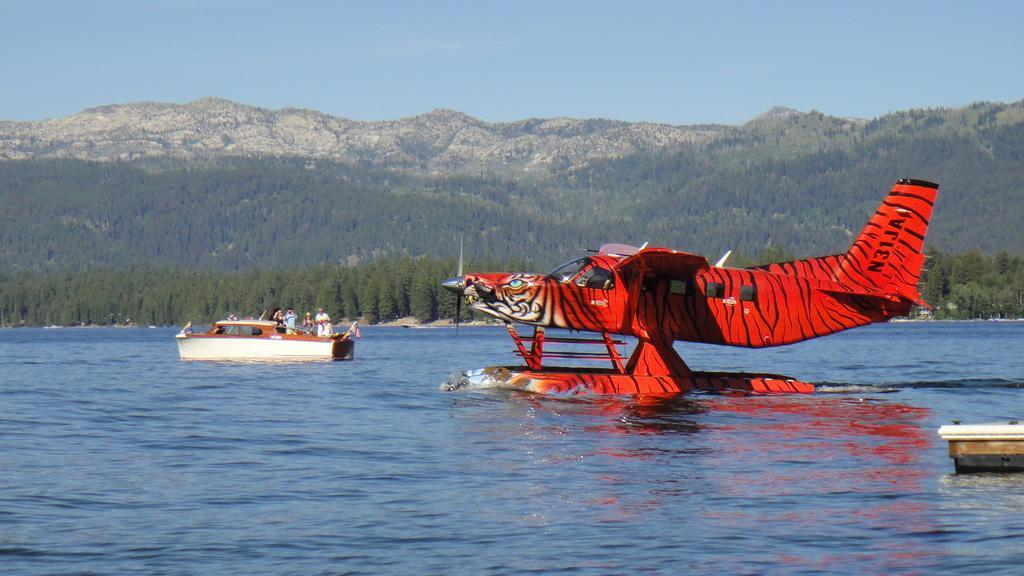In one or two sentences, can you explain what this image depicts? In the center of the image we can see one boat and one airplane on the water. In the boat, we can see one flag, four persons are standing and a few other objects. On the right side of the image, we can see one object. In the background we can see the sky, hills, trees, water and a few other objects. 